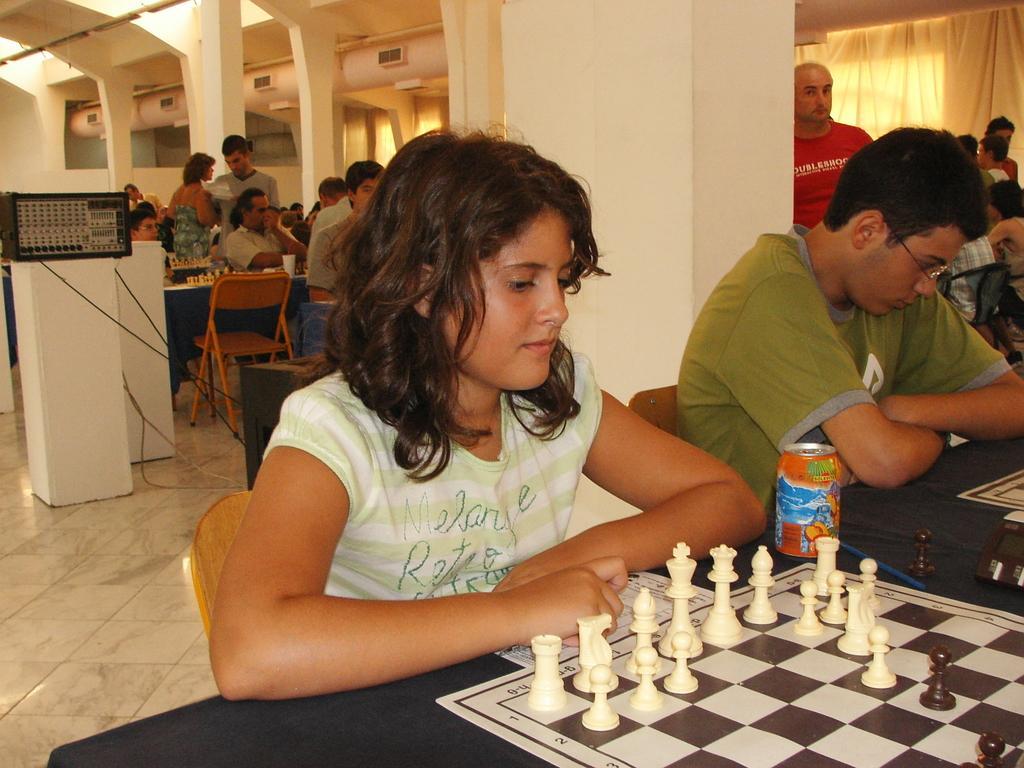In one or two sentences, can you explain what this image depicts? The front woman is sitting on a chair is looking at a chess board coins. On this table there is a chess board coins and tin. Most of the persons are sitting on the chair. On this table there is a electronic device. 